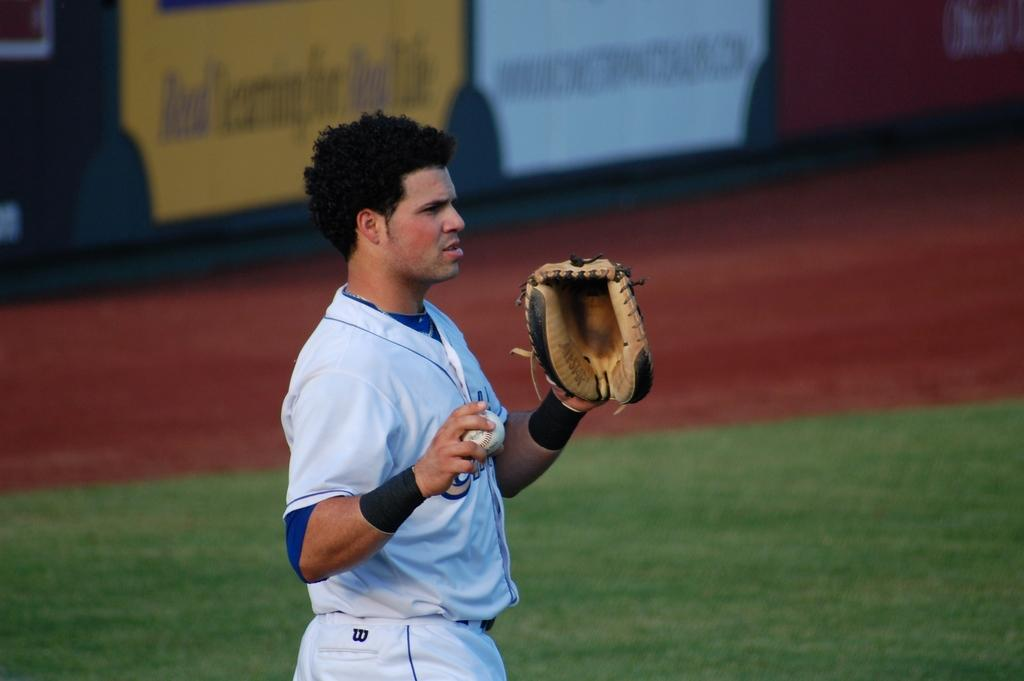Who is present in the image? There is a man in the image. What is the man wearing on his hand? The man is wearing a glove. What is the man holding in the image? The man is holding a ball. What type of surface is visible at the bottom of the image? There is green grass at the bottom of the image. What can be seen in the background of the image? There are books in the background of the image. What type of cattle can be seen grazing on the grass in the image? There are no cattle present in the image; it features a man holding a ball and green grass at the bottom. What belief system does the man in the image follow? There is no information about the man's belief system in the image. 